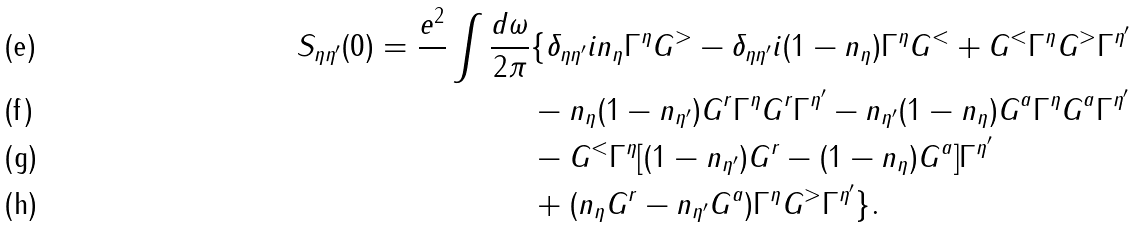<formula> <loc_0><loc_0><loc_500><loc_500>S _ { \eta \eta ^ { \prime } } ( 0 ) = \frac { e ^ { 2 } } { } \int \frac { d \omega } { 2 \pi } & \{ \delta _ { \eta \eta ^ { \prime } } i n _ { \eta } \Gamma ^ { \eta } G ^ { > } - \delta _ { \eta \eta ^ { \prime } } i ( 1 - n _ { \eta } ) \Gamma ^ { \eta } G ^ { < } + G ^ { < } \Gamma ^ { \eta } G ^ { > } \Gamma ^ { \eta ^ { \prime } } \\ & - n _ { \eta } ( 1 - n _ { \eta ^ { \prime } } ) G ^ { r } \Gamma ^ { \eta } G ^ { r } \Gamma ^ { \eta ^ { \prime } } - n _ { \eta ^ { \prime } } ( 1 - n _ { \eta } ) G ^ { a } \Gamma ^ { \eta } G ^ { a } \Gamma ^ { \eta ^ { \prime } } \\ & - G ^ { < } \Gamma ^ { \eta } [ ( 1 - n _ { \eta ^ { \prime } } ) G ^ { r } - ( 1 - n _ { \eta } ) G ^ { a } ] \Gamma ^ { \eta ^ { \prime } } \\ & + ( n _ { \eta } G ^ { r } - n _ { \eta ^ { \prime } } G ^ { a } ) \Gamma ^ { \eta } G ^ { > } \Gamma ^ { \eta ^ { \prime } } \} .</formula> 